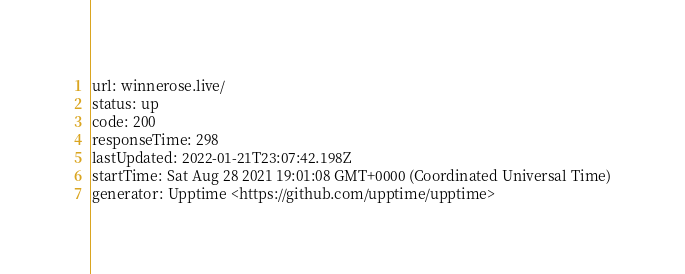Convert code to text. <code><loc_0><loc_0><loc_500><loc_500><_YAML_>url: winnerose.live/
status: up
code: 200
responseTime: 298
lastUpdated: 2022-01-21T23:07:42.198Z
startTime: Sat Aug 28 2021 19:01:08 GMT+0000 (Coordinated Universal Time)
generator: Upptime <https://github.com/upptime/upptime>
</code> 